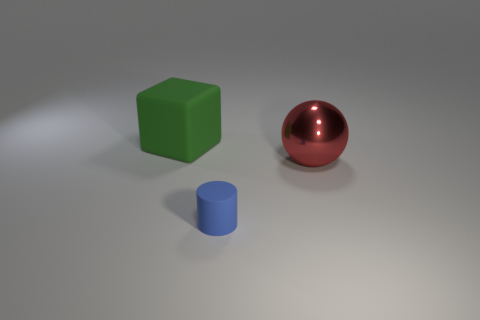Is there any other thing that is the same size as the red ball?
Ensure brevity in your answer.  Yes. What size is the green block that is the same material as the blue thing?
Your response must be concise. Large. Do the blue object and the shiny object have the same size?
Offer a terse response. No. What is the big red thing made of?
Ensure brevity in your answer.  Metal. The cube that is the same material as the blue thing is what color?
Offer a very short reply. Green. Is the material of the small cylinder the same as the thing that is behind the big red thing?
Your answer should be compact. Yes. How many cylinders have the same material as the red sphere?
Offer a very short reply. 0. There is a big thing on the right side of the small cylinder; what shape is it?
Make the answer very short. Sphere. Is the object that is behind the sphere made of the same material as the object that is to the right of the cylinder?
Your answer should be very brief. No. Is there a large green rubber object of the same shape as the large red thing?
Offer a terse response. No. 